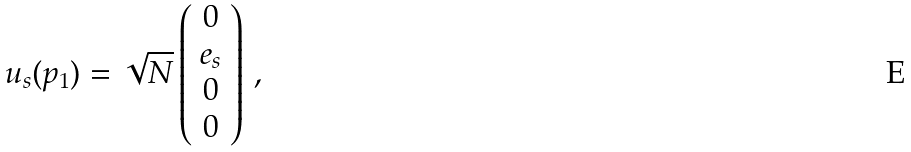<formula> <loc_0><loc_0><loc_500><loc_500>u _ { s } ( p _ { 1 } ) = \sqrt { N } \left ( \begin{array} { c } 0 \\ e _ { s } \\ 0 \\ 0 \end{array} \right ) \, ,</formula> 